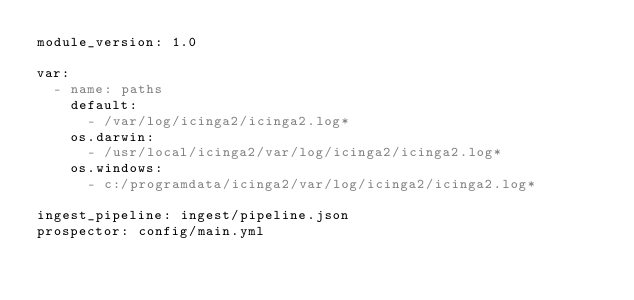Convert code to text. <code><loc_0><loc_0><loc_500><loc_500><_YAML_>module_version: 1.0

var:
  - name: paths
    default:
      - /var/log/icinga2/icinga2.log*
    os.darwin:
      - /usr/local/icinga2/var/log/icinga2/icinga2.log*
    os.windows:
      - c:/programdata/icinga2/var/log/icinga2/icinga2.log*

ingest_pipeline: ingest/pipeline.json
prospector: config/main.yml
</code> 